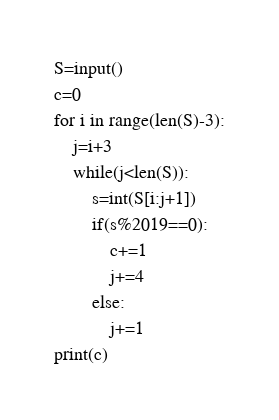<code> <loc_0><loc_0><loc_500><loc_500><_Python_>S=input()
c=0
for i in range(len(S)-3):
    j=i+3
    while(j<len(S)):
        s=int(S[i:j+1])
        if(s%2019==0):
            c+=1
            j+=4
        else:
            j+=1
print(c)</code> 